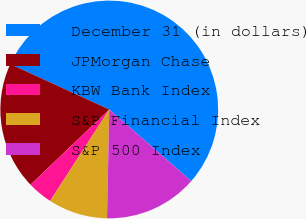Convert chart. <chart><loc_0><loc_0><loc_500><loc_500><pie_chart><fcel>December 31 (in dollars)<fcel>JPMorgan Chase<fcel>KBW Bank Index<fcel>S&P Financial Index<fcel>S&P 500 Index<nl><fcel>54.58%<fcel>18.98%<fcel>3.73%<fcel>8.81%<fcel>13.9%<nl></chart> 